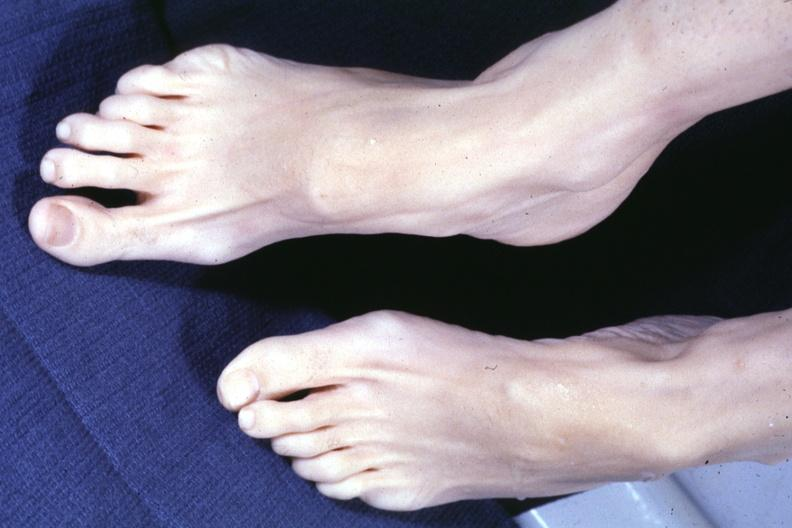do no cystic aortic lesions see other slide this interesting case?
Answer the question using a single word or phrase. Yes 